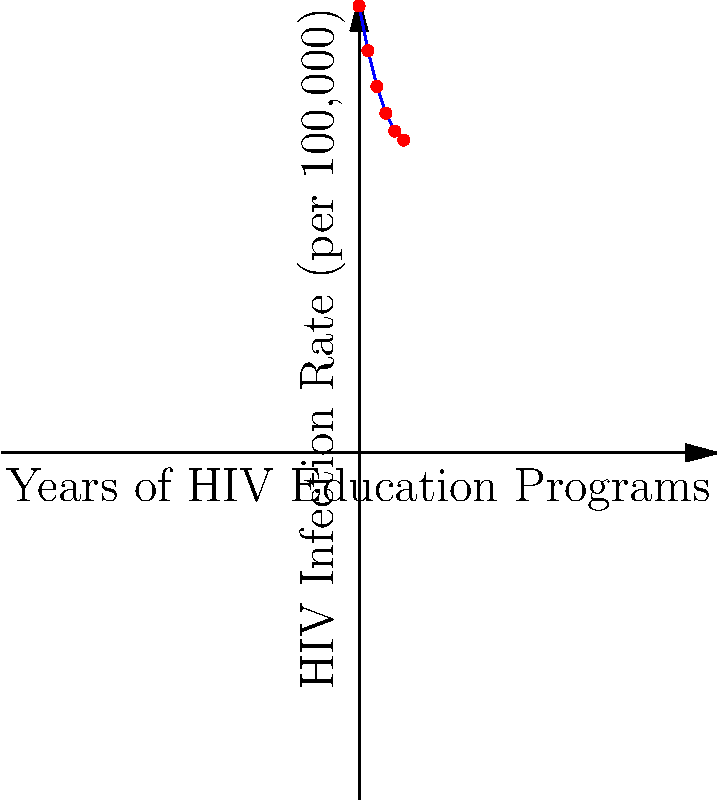In a study analyzing the effectiveness of HIV education programs, researchers plotted the relationship between years of program implementation and HIV infection rates. The graph shows a line of best fit for this data. Calculate the slope of this line and interpret its meaning in the context of HIV prevention efforts. To calculate the slope of the line, we'll use the formula:

$$ \text{slope} = \frac{y_2 - y_1}{x_2 - x_1} $$

Let's choose two points on the line:
$(x_1, y_1) = (0, 50)$ and $(x_2, y_2) = (5, 35)$

Plugging these into our formula:

$$ \text{slope} = \frac{35 - 50}{5 - 0} = \frac{-15}{5} = -3 $$

The slope is -3, which means:

1. The negative sign indicates an inverse relationship: as years of education increase, infection rates decrease.
2. For each year of HIV education program implementation, the HIV infection rate decreases by 3 per 100,000 people on average.

Interpretation:
This slope suggests that HIV education programs are effective in reducing infection rates. The -3 per 100,000 per year reduction indicates a significant impact of these programs on public health outcomes related to HIV.
Answer: -3 per 100,000 per year; indicates effective HIV prevention 